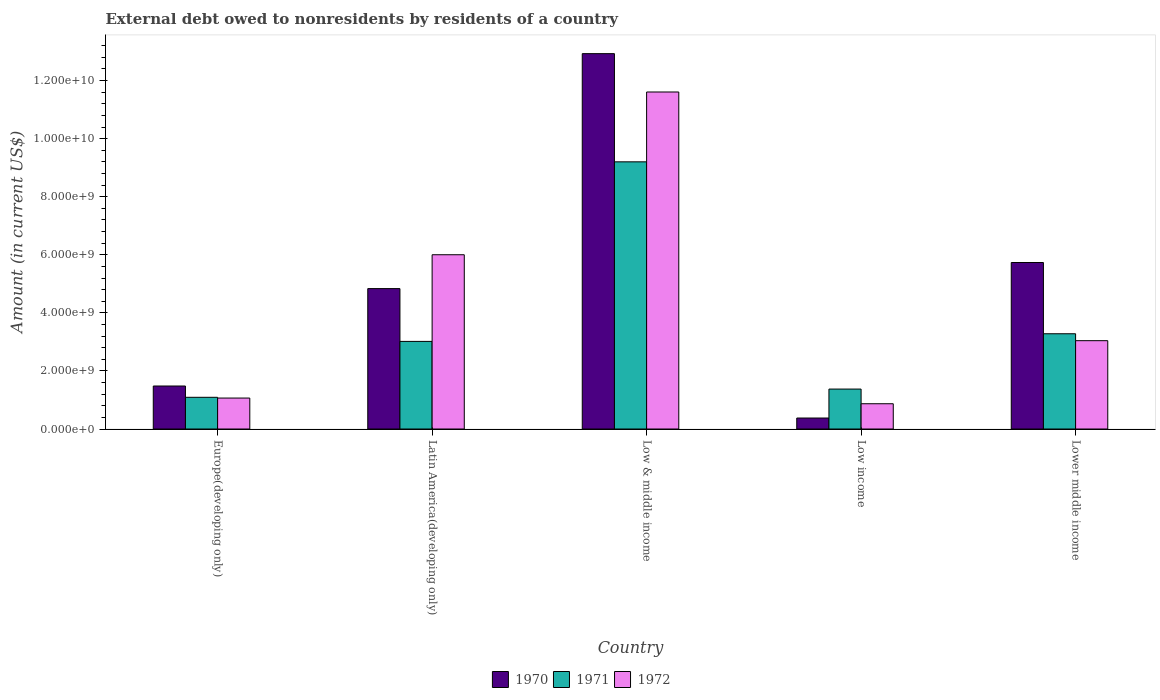How many different coloured bars are there?
Your answer should be very brief. 3. How many groups of bars are there?
Provide a short and direct response. 5. Are the number of bars per tick equal to the number of legend labels?
Ensure brevity in your answer.  Yes. Are the number of bars on each tick of the X-axis equal?
Give a very brief answer. Yes. How many bars are there on the 5th tick from the right?
Your answer should be very brief. 3. What is the label of the 5th group of bars from the left?
Your answer should be compact. Lower middle income. What is the external debt owed by residents in 1972 in Low & middle income?
Offer a terse response. 1.16e+1. Across all countries, what is the maximum external debt owed by residents in 1970?
Your answer should be very brief. 1.29e+1. Across all countries, what is the minimum external debt owed by residents in 1972?
Offer a very short reply. 8.71e+08. In which country was the external debt owed by residents in 1971 maximum?
Your response must be concise. Low & middle income. In which country was the external debt owed by residents in 1972 minimum?
Your answer should be compact. Low income. What is the total external debt owed by residents in 1972 in the graph?
Keep it short and to the point. 2.26e+1. What is the difference between the external debt owed by residents in 1971 in Europe(developing only) and that in Latin America(developing only)?
Give a very brief answer. -1.93e+09. What is the difference between the external debt owed by residents in 1972 in Low & middle income and the external debt owed by residents in 1970 in Europe(developing only)?
Provide a short and direct response. 1.01e+1. What is the average external debt owed by residents in 1970 per country?
Give a very brief answer. 5.07e+09. What is the difference between the external debt owed by residents of/in 1971 and external debt owed by residents of/in 1972 in Europe(developing only)?
Keep it short and to the point. 2.58e+07. What is the ratio of the external debt owed by residents in 1972 in Latin America(developing only) to that in Low & middle income?
Offer a terse response. 0.52. Is the external debt owed by residents in 1972 in Latin America(developing only) less than that in Lower middle income?
Ensure brevity in your answer.  No. What is the difference between the highest and the second highest external debt owed by residents in 1972?
Your answer should be compact. 5.61e+09. What is the difference between the highest and the lowest external debt owed by residents in 1971?
Your response must be concise. 8.11e+09. Is the sum of the external debt owed by residents in 1971 in Low income and Lower middle income greater than the maximum external debt owed by residents in 1970 across all countries?
Your answer should be very brief. No. Is it the case that in every country, the sum of the external debt owed by residents in 1971 and external debt owed by residents in 1972 is greater than the external debt owed by residents in 1970?
Ensure brevity in your answer.  Yes. How many bars are there?
Offer a terse response. 15. How many countries are there in the graph?
Give a very brief answer. 5. Are the values on the major ticks of Y-axis written in scientific E-notation?
Make the answer very short. Yes. Does the graph contain any zero values?
Ensure brevity in your answer.  No. Where does the legend appear in the graph?
Offer a terse response. Bottom center. How many legend labels are there?
Offer a very short reply. 3. How are the legend labels stacked?
Provide a short and direct response. Horizontal. What is the title of the graph?
Provide a short and direct response. External debt owed to nonresidents by residents of a country. Does "1960" appear as one of the legend labels in the graph?
Your answer should be compact. No. What is the label or title of the Y-axis?
Ensure brevity in your answer.  Amount (in current US$). What is the Amount (in current US$) of 1970 in Europe(developing only)?
Give a very brief answer. 1.48e+09. What is the Amount (in current US$) of 1971 in Europe(developing only)?
Give a very brief answer. 1.09e+09. What is the Amount (in current US$) of 1972 in Europe(developing only)?
Make the answer very short. 1.07e+09. What is the Amount (in current US$) of 1970 in Latin America(developing only)?
Your answer should be very brief. 4.84e+09. What is the Amount (in current US$) in 1971 in Latin America(developing only)?
Provide a short and direct response. 3.02e+09. What is the Amount (in current US$) of 1972 in Latin America(developing only)?
Your answer should be compact. 6.00e+09. What is the Amount (in current US$) in 1970 in Low & middle income?
Your answer should be compact. 1.29e+1. What is the Amount (in current US$) of 1971 in Low & middle income?
Make the answer very short. 9.20e+09. What is the Amount (in current US$) of 1972 in Low & middle income?
Ensure brevity in your answer.  1.16e+1. What is the Amount (in current US$) of 1970 in Low income?
Your answer should be very brief. 3.78e+08. What is the Amount (in current US$) in 1971 in Low income?
Give a very brief answer. 1.38e+09. What is the Amount (in current US$) of 1972 in Low income?
Provide a succinct answer. 8.71e+08. What is the Amount (in current US$) of 1970 in Lower middle income?
Give a very brief answer. 5.73e+09. What is the Amount (in current US$) of 1971 in Lower middle income?
Offer a terse response. 3.28e+09. What is the Amount (in current US$) of 1972 in Lower middle income?
Your answer should be compact. 3.04e+09. Across all countries, what is the maximum Amount (in current US$) of 1970?
Ensure brevity in your answer.  1.29e+1. Across all countries, what is the maximum Amount (in current US$) of 1971?
Provide a short and direct response. 9.20e+09. Across all countries, what is the maximum Amount (in current US$) of 1972?
Provide a succinct answer. 1.16e+1. Across all countries, what is the minimum Amount (in current US$) of 1970?
Offer a terse response. 3.78e+08. Across all countries, what is the minimum Amount (in current US$) in 1971?
Offer a terse response. 1.09e+09. Across all countries, what is the minimum Amount (in current US$) in 1972?
Keep it short and to the point. 8.71e+08. What is the total Amount (in current US$) in 1970 in the graph?
Make the answer very short. 2.54e+1. What is the total Amount (in current US$) in 1971 in the graph?
Make the answer very short. 1.80e+1. What is the total Amount (in current US$) in 1972 in the graph?
Your answer should be very brief. 2.26e+1. What is the difference between the Amount (in current US$) of 1970 in Europe(developing only) and that in Latin America(developing only)?
Your answer should be very brief. -3.35e+09. What is the difference between the Amount (in current US$) of 1971 in Europe(developing only) and that in Latin America(developing only)?
Provide a short and direct response. -1.93e+09. What is the difference between the Amount (in current US$) of 1972 in Europe(developing only) and that in Latin America(developing only)?
Your response must be concise. -4.94e+09. What is the difference between the Amount (in current US$) of 1970 in Europe(developing only) and that in Low & middle income?
Provide a short and direct response. -1.14e+1. What is the difference between the Amount (in current US$) in 1971 in Europe(developing only) and that in Low & middle income?
Keep it short and to the point. -8.11e+09. What is the difference between the Amount (in current US$) in 1972 in Europe(developing only) and that in Low & middle income?
Provide a short and direct response. -1.05e+1. What is the difference between the Amount (in current US$) in 1970 in Europe(developing only) and that in Low income?
Your answer should be very brief. 1.10e+09. What is the difference between the Amount (in current US$) of 1971 in Europe(developing only) and that in Low income?
Offer a very short reply. -2.84e+08. What is the difference between the Amount (in current US$) of 1972 in Europe(developing only) and that in Low income?
Your answer should be compact. 1.96e+08. What is the difference between the Amount (in current US$) of 1970 in Europe(developing only) and that in Lower middle income?
Ensure brevity in your answer.  -4.25e+09. What is the difference between the Amount (in current US$) in 1971 in Europe(developing only) and that in Lower middle income?
Keep it short and to the point. -2.19e+09. What is the difference between the Amount (in current US$) in 1972 in Europe(developing only) and that in Lower middle income?
Make the answer very short. -1.98e+09. What is the difference between the Amount (in current US$) of 1970 in Latin America(developing only) and that in Low & middle income?
Provide a succinct answer. -8.09e+09. What is the difference between the Amount (in current US$) of 1971 in Latin America(developing only) and that in Low & middle income?
Give a very brief answer. -6.18e+09. What is the difference between the Amount (in current US$) of 1972 in Latin America(developing only) and that in Low & middle income?
Your answer should be compact. -5.61e+09. What is the difference between the Amount (in current US$) of 1970 in Latin America(developing only) and that in Low income?
Provide a short and direct response. 4.46e+09. What is the difference between the Amount (in current US$) in 1971 in Latin America(developing only) and that in Low income?
Give a very brief answer. 1.64e+09. What is the difference between the Amount (in current US$) of 1972 in Latin America(developing only) and that in Low income?
Keep it short and to the point. 5.13e+09. What is the difference between the Amount (in current US$) in 1970 in Latin America(developing only) and that in Lower middle income?
Your response must be concise. -8.99e+08. What is the difference between the Amount (in current US$) in 1971 in Latin America(developing only) and that in Lower middle income?
Keep it short and to the point. -2.63e+08. What is the difference between the Amount (in current US$) in 1972 in Latin America(developing only) and that in Lower middle income?
Provide a short and direct response. 2.96e+09. What is the difference between the Amount (in current US$) of 1970 in Low & middle income and that in Low income?
Your response must be concise. 1.25e+1. What is the difference between the Amount (in current US$) of 1971 in Low & middle income and that in Low income?
Offer a terse response. 7.83e+09. What is the difference between the Amount (in current US$) of 1972 in Low & middle income and that in Low income?
Give a very brief answer. 1.07e+1. What is the difference between the Amount (in current US$) of 1970 in Low & middle income and that in Lower middle income?
Ensure brevity in your answer.  7.19e+09. What is the difference between the Amount (in current US$) of 1971 in Low & middle income and that in Lower middle income?
Your answer should be compact. 5.92e+09. What is the difference between the Amount (in current US$) in 1972 in Low & middle income and that in Lower middle income?
Your answer should be very brief. 8.57e+09. What is the difference between the Amount (in current US$) of 1970 in Low income and that in Lower middle income?
Provide a short and direct response. -5.36e+09. What is the difference between the Amount (in current US$) of 1971 in Low income and that in Lower middle income?
Provide a succinct answer. -1.90e+09. What is the difference between the Amount (in current US$) of 1972 in Low income and that in Lower middle income?
Offer a very short reply. -2.17e+09. What is the difference between the Amount (in current US$) in 1970 in Europe(developing only) and the Amount (in current US$) in 1971 in Latin America(developing only)?
Make the answer very short. -1.54e+09. What is the difference between the Amount (in current US$) of 1970 in Europe(developing only) and the Amount (in current US$) of 1972 in Latin America(developing only)?
Offer a very short reply. -4.52e+09. What is the difference between the Amount (in current US$) in 1971 in Europe(developing only) and the Amount (in current US$) in 1972 in Latin America(developing only)?
Offer a terse response. -4.91e+09. What is the difference between the Amount (in current US$) in 1970 in Europe(developing only) and the Amount (in current US$) in 1971 in Low & middle income?
Your response must be concise. -7.72e+09. What is the difference between the Amount (in current US$) of 1970 in Europe(developing only) and the Amount (in current US$) of 1972 in Low & middle income?
Make the answer very short. -1.01e+1. What is the difference between the Amount (in current US$) in 1971 in Europe(developing only) and the Amount (in current US$) in 1972 in Low & middle income?
Your answer should be compact. -1.05e+1. What is the difference between the Amount (in current US$) of 1970 in Europe(developing only) and the Amount (in current US$) of 1971 in Low income?
Give a very brief answer. 1.05e+08. What is the difference between the Amount (in current US$) in 1970 in Europe(developing only) and the Amount (in current US$) in 1972 in Low income?
Your response must be concise. 6.10e+08. What is the difference between the Amount (in current US$) in 1971 in Europe(developing only) and the Amount (in current US$) in 1972 in Low income?
Offer a very short reply. 2.22e+08. What is the difference between the Amount (in current US$) in 1970 in Europe(developing only) and the Amount (in current US$) in 1971 in Lower middle income?
Provide a short and direct response. -1.80e+09. What is the difference between the Amount (in current US$) in 1970 in Europe(developing only) and the Amount (in current US$) in 1972 in Lower middle income?
Give a very brief answer. -1.56e+09. What is the difference between the Amount (in current US$) of 1971 in Europe(developing only) and the Amount (in current US$) of 1972 in Lower middle income?
Your response must be concise. -1.95e+09. What is the difference between the Amount (in current US$) of 1970 in Latin America(developing only) and the Amount (in current US$) of 1971 in Low & middle income?
Give a very brief answer. -4.37e+09. What is the difference between the Amount (in current US$) of 1970 in Latin America(developing only) and the Amount (in current US$) of 1972 in Low & middle income?
Keep it short and to the point. -6.77e+09. What is the difference between the Amount (in current US$) of 1971 in Latin America(developing only) and the Amount (in current US$) of 1972 in Low & middle income?
Provide a short and direct response. -8.59e+09. What is the difference between the Amount (in current US$) in 1970 in Latin America(developing only) and the Amount (in current US$) in 1971 in Low income?
Ensure brevity in your answer.  3.46e+09. What is the difference between the Amount (in current US$) of 1970 in Latin America(developing only) and the Amount (in current US$) of 1972 in Low income?
Offer a very short reply. 3.97e+09. What is the difference between the Amount (in current US$) of 1971 in Latin America(developing only) and the Amount (in current US$) of 1972 in Low income?
Your answer should be very brief. 2.15e+09. What is the difference between the Amount (in current US$) of 1970 in Latin America(developing only) and the Amount (in current US$) of 1971 in Lower middle income?
Provide a short and direct response. 1.56e+09. What is the difference between the Amount (in current US$) in 1970 in Latin America(developing only) and the Amount (in current US$) in 1972 in Lower middle income?
Provide a short and direct response. 1.79e+09. What is the difference between the Amount (in current US$) of 1971 in Latin America(developing only) and the Amount (in current US$) of 1972 in Lower middle income?
Your answer should be very brief. -2.46e+07. What is the difference between the Amount (in current US$) in 1970 in Low & middle income and the Amount (in current US$) in 1971 in Low income?
Provide a succinct answer. 1.16e+1. What is the difference between the Amount (in current US$) in 1970 in Low & middle income and the Amount (in current US$) in 1972 in Low income?
Your answer should be very brief. 1.21e+1. What is the difference between the Amount (in current US$) in 1971 in Low & middle income and the Amount (in current US$) in 1972 in Low income?
Your answer should be compact. 8.33e+09. What is the difference between the Amount (in current US$) in 1970 in Low & middle income and the Amount (in current US$) in 1971 in Lower middle income?
Make the answer very short. 9.65e+09. What is the difference between the Amount (in current US$) in 1970 in Low & middle income and the Amount (in current US$) in 1972 in Lower middle income?
Offer a very short reply. 9.89e+09. What is the difference between the Amount (in current US$) in 1971 in Low & middle income and the Amount (in current US$) in 1972 in Lower middle income?
Make the answer very short. 6.16e+09. What is the difference between the Amount (in current US$) in 1970 in Low income and the Amount (in current US$) in 1971 in Lower middle income?
Make the answer very short. -2.90e+09. What is the difference between the Amount (in current US$) in 1970 in Low income and the Amount (in current US$) in 1972 in Lower middle income?
Provide a succinct answer. -2.66e+09. What is the difference between the Amount (in current US$) of 1971 in Low income and the Amount (in current US$) of 1972 in Lower middle income?
Provide a succinct answer. -1.67e+09. What is the average Amount (in current US$) of 1970 per country?
Your response must be concise. 5.07e+09. What is the average Amount (in current US$) of 1971 per country?
Keep it short and to the point. 3.59e+09. What is the average Amount (in current US$) of 1972 per country?
Offer a terse response. 4.52e+09. What is the difference between the Amount (in current US$) of 1970 and Amount (in current US$) of 1971 in Europe(developing only)?
Provide a succinct answer. 3.89e+08. What is the difference between the Amount (in current US$) in 1970 and Amount (in current US$) in 1972 in Europe(developing only)?
Your response must be concise. 4.15e+08. What is the difference between the Amount (in current US$) of 1971 and Amount (in current US$) of 1972 in Europe(developing only)?
Your answer should be compact. 2.58e+07. What is the difference between the Amount (in current US$) of 1970 and Amount (in current US$) of 1971 in Latin America(developing only)?
Offer a very short reply. 1.82e+09. What is the difference between the Amount (in current US$) of 1970 and Amount (in current US$) of 1972 in Latin America(developing only)?
Your answer should be very brief. -1.17e+09. What is the difference between the Amount (in current US$) of 1971 and Amount (in current US$) of 1972 in Latin America(developing only)?
Ensure brevity in your answer.  -2.98e+09. What is the difference between the Amount (in current US$) of 1970 and Amount (in current US$) of 1971 in Low & middle income?
Your answer should be very brief. 3.73e+09. What is the difference between the Amount (in current US$) of 1970 and Amount (in current US$) of 1972 in Low & middle income?
Make the answer very short. 1.32e+09. What is the difference between the Amount (in current US$) of 1971 and Amount (in current US$) of 1972 in Low & middle income?
Offer a very short reply. -2.41e+09. What is the difference between the Amount (in current US$) of 1970 and Amount (in current US$) of 1971 in Low income?
Offer a very short reply. -9.97e+08. What is the difference between the Amount (in current US$) in 1970 and Amount (in current US$) in 1972 in Low income?
Give a very brief answer. -4.92e+08. What is the difference between the Amount (in current US$) of 1971 and Amount (in current US$) of 1972 in Low income?
Your answer should be compact. 5.05e+08. What is the difference between the Amount (in current US$) of 1970 and Amount (in current US$) of 1971 in Lower middle income?
Give a very brief answer. 2.45e+09. What is the difference between the Amount (in current US$) of 1970 and Amount (in current US$) of 1972 in Lower middle income?
Provide a succinct answer. 2.69e+09. What is the difference between the Amount (in current US$) in 1971 and Amount (in current US$) in 1972 in Lower middle income?
Provide a short and direct response. 2.39e+08. What is the ratio of the Amount (in current US$) in 1970 in Europe(developing only) to that in Latin America(developing only)?
Ensure brevity in your answer.  0.31. What is the ratio of the Amount (in current US$) in 1971 in Europe(developing only) to that in Latin America(developing only)?
Give a very brief answer. 0.36. What is the ratio of the Amount (in current US$) in 1972 in Europe(developing only) to that in Latin America(developing only)?
Your response must be concise. 0.18. What is the ratio of the Amount (in current US$) of 1970 in Europe(developing only) to that in Low & middle income?
Ensure brevity in your answer.  0.11. What is the ratio of the Amount (in current US$) in 1971 in Europe(developing only) to that in Low & middle income?
Keep it short and to the point. 0.12. What is the ratio of the Amount (in current US$) of 1972 in Europe(developing only) to that in Low & middle income?
Provide a succinct answer. 0.09. What is the ratio of the Amount (in current US$) of 1970 in Europe(developing only) to that in Low income?
Provide a succinct answer. 3.91. What is the ratio of the Amount (in current US$) of 1971 in Europe(developing only) to that in Low income?
Your response must be concise. 0.79. What is the ratio of the Amount (in current US$) of 1972 in Europe(developing only) to that in Low income?
Offer a terse response. 1.22. What is the ratio of the Amount (in current US$) of 1970 in Europe(developing only) to that in Lower middle income?
Keep it short and to the point. 0.26. What is the ratio of the Amount (in current US$) of 1971 in Europe(developing only) to that in Lower middle income?
Provide a short and direct response. 0.33. What is the ratio of the Amount (in current US$) of 1972 in Europe(developing only) to that in Lower middle income?
Offer a very short reply. 0.35. What is the ratio of the Amount (in current US$) in 1970 in Latin America(developing only) to that in Low & middle income?
Make the answer very short. 0.37. What is the ratio of the Amount (in current US$) of 1971 in Latin America(developing only) to that in Low & middle income?
Offer a very short reply. 0.33. What is the ratio of the Amount (in current US$) of 1972 in Latin America(developing only) to that in Low & middle income?
Ensure brevity in your answer.  0.52. What is the ratio of the Amount (in current US$) in 1970 in Latin America(developing only) to that in Low income?
Provide a succinct answer. 12.78. What is the ratio of the Amount (in current US$) in 1971 in Latin America(developing only) to that in Low income?
Provide a short and direct response. 2.19. What is the ratio of the Amount (in current US$) in 1972 in Latin America(developing only) to that in Low income?
Provide a short and direct response. 6.89. What is the ratio of the Amount (in current US$) in 1970 in Latin America(developing only) to that in Lower middle income?
Your answer should be compact. 0.84. What is the ratio of the Amount (in current US$) of 1971 in Latin America(developing only) to that in Lower middle income?
Your answer should be compact. 0.92. What is the ratio of the Amount (in current US$) of 1972 in Latin America(developing only) to that in Lower middle income?
Give a very brief answer. 1.97. What is the ratio of the Amount (in current US$) of 1970 in Low & middle income to that in Low income?
Keep it short and to the point. 34.16. What is the ratio of the Amount (in current US$) in 1971 in Low & middle income to that in Low income?
Ensure brevity in your answer.  6.69. What is the ratio of the Amount (in current US$) in 1972 in Low & middle income to that in Low income?
Your response must be concise. 13.33. What is the ratio of the Amount (in current US$) in 1970 in Low & middle income to that in Lower middle income?
Provide a short and direct response. 2.25. What is the ratio of the Amount (in current US$) in 1971 in Low & middle income to that in Lower middle income?
Your answer should be very brief. 2.8. What is the ratio of the Amount (in current US$) in 1972 in Low & middle income to that in Lower middle income?
Your answer should be very brief. 3.82. What is the ratio of the Amount (in current US$) of 1970 in Low income to that in Lower middle income?
Provide a succinct answer. 0.07. What is the ratio of the Amount (in current US$) of 1971 in Low income to that in Lower middle income?
Provide a short and direct response. 0.42. What is the ratio of the Amount (in current US$) of 1972 in Low income to that in Lower middle income?
Ensure brevity in your answer.  0.29. What is the difference between the highest and the second highest Amount (in current US$) in 1970?
Provide a short and direct response. 7.19e+09. What is the difference between the highest and the second highest Amount (in current US$) of 1971?
Keep it short and to the point. 5.92e+09. What is the difference between the highest and the second highest Amount (in current US$) in 1972?
Make the answer very short. 5.61e+09. What is the difference between the highest and the lowest Amount (in current US$) of 1970?
Give a very brief answer. 1.25e+1. What is the difference between the highest and the lowest Amount (in current US$) in 1971?
Make the answer very short. 8.11e+09. What is the difference between the highest and the lowest Amount (in current US$) in 1972?
Keep it short and to the point. 1.07e+1. 